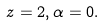<formula> <loc_0><loc_0><loc_500><loc_500>z = 2 , \alpha = 0 .</formula> 